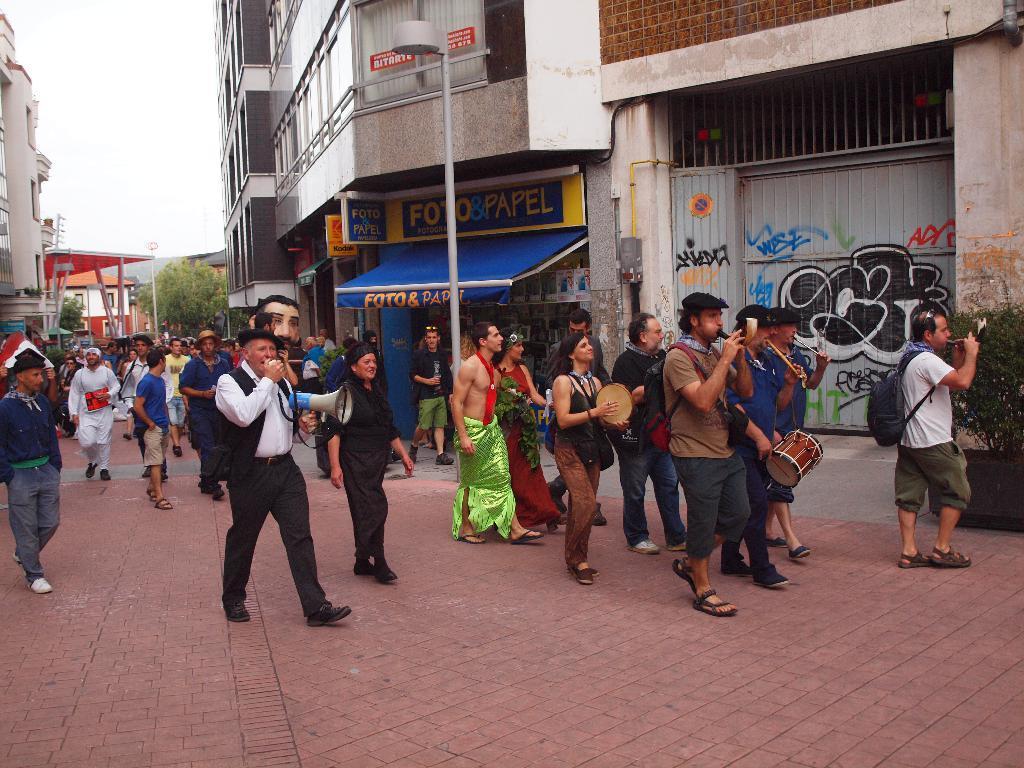Describe this image in one or two sentences. In this picture there are group of people playing musical instruments. There is a person wearing bag. There is another person holding loudspeaker in his hand. There are buildings to the right and left. There is a tree, street light. 